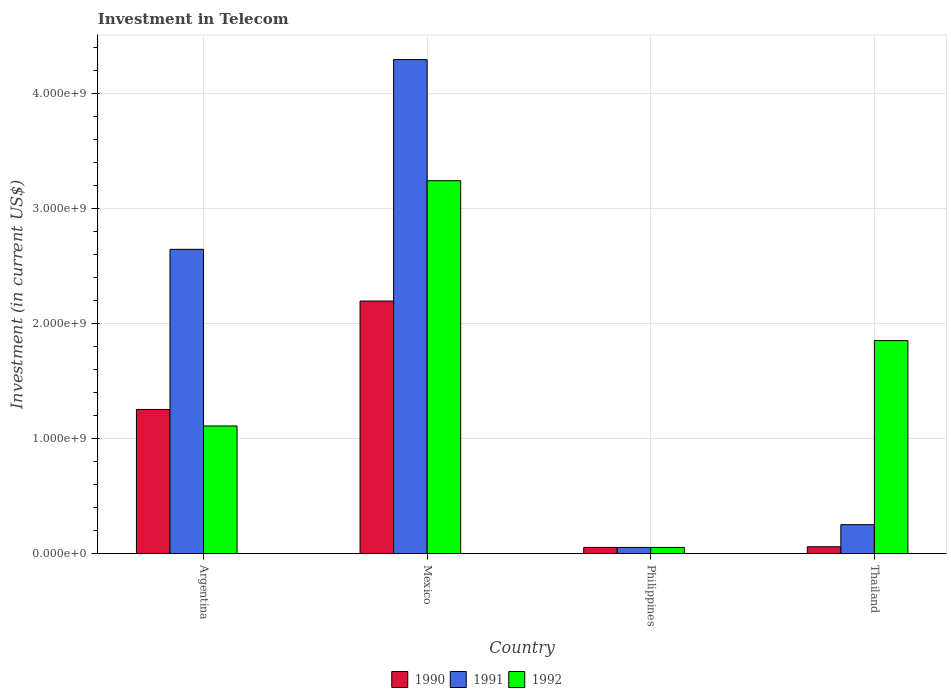How many groups of bars are there?
Offer a terse response. 4. How many bars are there on the 4th tick from the right?
Give a very brief answer. 3. What is the label of the 3rd group of bars from the left?
Make the answer very short. Philippines. What is the amount invested in telecom in 1990 in Mexico?
Offer a very short reply. 2.20e+09. Across all countries, what is the maximum amount invested in telecom in 1992?
Provide a succinct answer. 3.24e+09. Across all countries, what is the minimum amount invested in telecom in 1992?
Offer a very short reply. 5.42e+07. In which country was the amount invested in telecom in 1991 maximum?
Offer a very short reply. Mexico. In which country was the amount invested in telecom in 1991 minimum?
Provide a succinct answer. Philippines. What is the total amount invested in telecom in 1992 in the graph?
Offer a very short reply. 6.26e+09. What is the difference between the amount invested in telecom in 1990 in Argentina and that in Thailand?
Ensure brevity in your answer.  1.19e+09. What is the difference between the amount invested in telecom in 1992 in Mexico and the amount invested in telecom in 1991 in Philippines?
Make the answer very short. 3.19e+09. What is the average amount invested in telecom in 1992 per country?
Your answer should be compact. 1.57e+09. What is the difference between the amount invested in telecom of/in 1991 and amount invested in telecom of/in 1990 in Thailand?
Make the answer very short. 1.92e+08. In how many countries, is the amount invested in telecom in 1992 greater than 2200000000 US$?
Your response must be concise. 1. What is the ratio of the amount invested in telecom in 1992 in Argentina to that in Mexico?
Make the answer very short. 0.34. What is the difference between the highest and the second highest amount invested in telecom in 1990?
Make the answer very short. 2.14e+09. What is the difference between the highest and the lowest amount invested in telecom in 1992?
Keep it short and to the point. 3.19e+09. In how many countries, is the amount invested in telecom in 1990 greater than the average amount invested in telecom in 1990 taken over all countries?
Make the answer very short. 2. What does the 2nd bar from the left in Mexico represents?
Ensure brevity in your answer.  1991. How many bars are there?
Provide a succinct answer. 12. Are all the bars in the graph horizontal?
Provide a succinct answer. No. How many countries are there in the graph?
Ensure brevity in your answer.  4. What is the difference between two consecutive major ticks on the Y-axis?
Keep it short and to the point. 1.00e+09. Does the graph contain any zero values?
Make the answer very short. No. Does the graph contain grids?
Offer a terse response. Yes. How are the legend labels stacked?
Ensure brevity in your answer.  Horizontal. What is the title of the graph?
Offer a very short reply. Investment in Telecom. Does "2009" appear as one of the legend labels in the graph?
Offer a very short reply. No. What is the label or title of the Y-axis?
Offer a very short reply. Investment (in current US$). What is the Investment (in current US$) of 1990 in Argentina?
Your answer should be compact. 1.25e+09. What is the Investment (in current US$) in 1991 in Argentina?
Your response must be concise. 2.65e+09. What is the Investment (in current US$) in 1992 in Argentina?
Provide a succinct answer. 1.11e+09. What is the Investment (in current US$) of 1990 in Mexico?
Your answer should be very brief. 2.20e+09. What is the Investment (in current US$) in 1991 in Mexico?
Give a very brief answer. 4.30e+09. What is the Investment (in current US$) of 1992 in Mexico?
Your response must be concise. 3.24e+09. What is the Investment (in current US$) of 1990 in Philippines?
Provide a succinct answer. 5.42e+07. What is the Investment (in current US$) of 1991 in Philippines?
Offer a very short reply. 5.42e+07. What is the Investment (in current US$) of 1992 in Philippines?
Provide a succinct answer. 5.42e+07. What is the Investment (in current US$) in 1990 in Thailand?
Your response must be concise. 6.00e+07. What is the Investment (in current US$) of 1991 in Thailand?
Keep it short and to the point. 2.52e+08. What is the Investment (in current US$) of 1992 in Thailand?
Ensure brevity in your answer.  1.85e+09. Across all countries, what is the maximum Investment (in current US$) in 1990?
Offer a very short reply. 2.20e+09. Across all countries, what is the maximum Investment (in current US$) of 1991?
Make the answer very short. 4.30e+09. Across all countries, what is the maximum Investment (in current US$) in 1992?
Keep it short and to the point. 3.24e+09. Across all countries, what is the minimum Investment (in current US$) in 1990?
Make the answer very short. 5.42e+07. Across all countries, what is the minimum Investment (in current US$) in 1991?
Provide a succinct answer. 5.42e+07. Across all countries, what is the minimum Investment (in current US$) of 1992?
Ensure brevity in your answer.  5.42e+07. What is the total Investment (in current US$) of 1990 in the graph?
Make the answer very short. 3.57e+09. What is the total Investment (in current US$) in 1991 in the graph?
Provide a short and direct response. 7.25e+09. What is the total Investment (in current US$) of 1992 in the graph?
Provide a succinct answer. 6.26e+09. What is the difference between the Investment (in current US$) of 1990 in Argentina and that in Mexico?
Keep it short and to the point. -9.43e+08. What is the difference between the Investment (in current US$) of 1991 in Argentina and that in Mexico?
Keep it short and to the point. -1.65e+09. What is the difference between the Investment (in current US$) of 1992 in Argentina and that in Mexico?
Your answer should be compact. -2.13e+09. What is the difference between the Investment (in current US$) of 1990 in Argentina and that in Philippines?
Keep it short and to the point. 1.20e+09. What is the difference between the Investment (in current US$) in 1991 in Argentina and that in Philippines?
Your response must be concise. 2.59e+09. What is the difference between the Investment (in current US$) of 1992 in Argentina and that in Philippines?
Your answer should be compact. 1.06e+09. What is the difference between the Investment (in current US$) in 1990 in Argentina and that in Thailand?
Ensure brevity in your answer.  1.19e+09. What is the difference between the Investment (in current US$) in 1991 in Argentina and that in Thailand?
Ensure brevity in your answer.  2.40e+09. What is the difference between the Investment (in current US$) in 1992 in Argentina and that in Thailand?
Keep it short and to the point. -7.43e+08. What is the difference between the Investment (in current US$) of 1990 in Mexico and that in Philippines?
Provide a short and direct response. 2.14e+09. What is the difference between the Investment (in current US$) of 1991 in Mexico and that in Philippines?
Offer a very short reply. 4.24e+09. What is the difference between the Investment (in current US$) in 1992 in Mexico and that in Philippines?
Give a very brief answer. 3.19e+09. What is the difference between the Investment (in current US$) in 1990 in Mexico and that in Thailand?
Offer a terse response. 2.14e+09. What is the difference between the Investment (in current US$) in 1991 in Mexico and that in Thailand?
Keep it short and to the point. 4.05e+09. What is the difference between the Investment (in current US$) in 1992 in Mexico and that in Thailand?
Keep it short and to the point. 1.39e+09. What is the difference between the Investment (in current US$) of 1990 in Philippines and that in Thailand?
Your answer should be compact. -5.80e+06. What is the difference between the Investment (in current US$) of 1991 in Philippines and that in Thailand?
Offer a terse response. -1.98e+08. What is the difference between the Investment (in current US$) of 1992 in Philippines and that in Thailand?
Your answer should be compact. -1.80e+09. What is the difference between the Investment (in current US$) in 1990 in Argentina and the Investment (in current US$) in 1991 in Mexico?
Provide a short and direct response. -3.04e+09. What is the difference between the Investment (in current US$) of 1990 in Argentina and the Investment (in current US$) of 1992 in Mexico?
Ensure brevity in your answer.  -1.99e+09. What is the difference between the Investment (in current US$) in 1991 in Argentina and the Investment (in current US$) in 1992 in Mexico?
Offer a very short reply. -5.97e+08. What is the difference between the Investment (in current US$) of 1990 in Argentina and the Investment (in current US$) of 1991 in Philippines?
Provide a succinct answer. 1.20e+09. What is the difference between the Investment (in current US$) of 1990 in Argentina and the Investment (in current US$) of 1992 in Philippines?
Your response must be concise. 1.20e+09. What is the difference between the Investment (in current US$) of 1991 in Argentina and the Investment (in current US$) of 1992 in Philippines?
Make the answer very short. 2.59e+09. What is the difference between the Investment (in current US$) of 1990 in Argentina and the Investment (in current US$) of 1991 in Thailand?
Provide a succinct answer. 1.00e+09. What is the difference between the Investment (in current US$) of 1990 in Argentina and the Investment (in current US$) of 1992 in Thailand?
Provide a short and direct response. -5.99e+08. What is the difference between the Investment (in current US$) in 1991 in Argentina and the Investment (in current US$) in 1992 in Thailand?
Keep it short and to the point. 7.94e+08. What is the difference between the Investment (in current US$) in 1990 in Mexico and the Investment (in current US$) in 1991 in Philippines?
Make the answer very short. 2.14e+09. What is the difference between the Investment (in current US$) of 1990 in Mexico and the Investment (in current US$) of 1992 in Philippines?
Make the answer very short. 2.14e+09. What is the difference between the Investment (in current US$) in 1991 in Mexico and the Investment (in current US$) in 1992 in Philippines?
Your answer should be very brief. 4.24e+09. What is the difference between the Investment (in current US$) of 1990 in Mexico and the Investment (in current US$) of 1991 in Thailand?
Provide a succinct answer. 1.95e+09. What is the difference between the Investment (in current US$) of 1990 in Mexico and the Investment (in current US$) of 1992 in Thailand?
Offer a very short reply. 3.44e+08. What is the difference between the Investment (in current US$) in 1991 in Mexico and the Investment (in current US$) in 1992 in Thailand?
Your answer should be compact. 2.44e+09. What is the difference between the Investment (in current US$) in 1990 in Philippines and the Investment (in current US$) in 1991 in Thailand?
Your response must be concise. -1.98e+08. What is the difference between the Investment (in current US$) in 1990 in Philippines and the Investment (in current US$) in 1992 in Thailand?
Give a very brief answer. -1.80e+09. What is the difference between the Investment (in current US$) of 1991 in Philippines and the Investment (in current US$) of 1992 in Thailand?
Your answer should be compact. -1.80e+09. What is the average Investment (in current US$) of 1990 per country?
Make the answer very short. 8.92e+08. What is the average Investment (in current US$) in 1991 per country?
Offer a very short reply. 1.81e+09. What is the average Investment (in current US$) in 1992 per country?
Ensure brevity in your answer.  1.57e+09. What is the difference between the Investment (in current US$) of 1990 and Investment (in current US$) of 1991 in Argentina?
Offer a very short reply. -1.39e+09. What is the difference between the Investment (in current US$) of 1990 and Investment (in current US$) of 1992 in Argentina?
Offer a terse response. 1.44e+08. What is the difference between the Investment (in current US$) in 1991 and Investment (in current US$) in 1992 in Argentina?
Your response must be concise. 1.54e+09. What is the difference between the Investment (in current US$) of 1990 and Investment (in current US$) of 1991 in Mexico?
Provide a short and direct response. -2.10e+09. What is the difference between the Investment (in current US$) in 1990 and Investment (in current US$) in 1992 in Mexico?
Offer a terse response. -1.05e+09. What is the difference between the Investment (in current US$) in 1991 and Investment (in current US$) in 1992 in Mexico?
Ensure brevity in your answer.  1.05e+09. What is the difference between the Investment (in current US$) in 1990 and Investment (in current US$) in 1991 in Philippines?
Your answer should be very brief. 0. What is the difference between the Investment (in current US$) of 1990 and Investment (in current US$) of 1992 in Philippines?
Make the answer very short. 0. What is the difference between the Investment (in current US$) of 1991 and Investment (in current US$) of 1992 in Philippines?
Offer a very short reply. 0. What is the difference between the Investment (in current US$) in 1990 and Investment (in current US$) in 1991 in Thailand?
Offer a very short reply. -1.92e+08. What is the difference between the Investment (in current US$) in 1990 and Investment (in current US$) in 1992 in Thailand?
Provide a succinct answer. -1.79e+09. What is the difference between the Investment (in current US$) in 1991 and Investment (in current US$) in 1992 in Thailand?
Make the answer very short. -1.60e+09. What is the ratio of the Investment (in current US$) of 1990 in Argentina to that in Mexico?
Ensure brevity in your answer.  0.57. What is the ratio of the Investment (in current US$) of 1991 in Argentina to that in Mexico?
Ensure brevity in your answer.  0.62. What is the ratio of the Investment (in current US$) of 1992 in Argentina to that in Mexico?
Your answer should be compact. 0.34. What is the ratio of the Investment (in current US$) in 1990 in Argentina to that in Philippines?
Provide a short and direct response. 23.15. What is the ratio of the Investment (in current US$) of 1991 in Argentina to that in Philippines?
Provide a short and direct response. 48.86. What is the ratio of the Investment (in current US$) in 1992 in Argentina to that in Philippines?
Provide a short and direct response. 20.5. What is the ratio of the Investment (in current US$) in 1990 in Argentina to that in Thailand?
Keep it short and to the point. 20.91. What is the ratio of the Investment (in current US$) in 1991 in Argentina to that in Thailand?
Your response must be concise. 10.51. What is the ratio of the Investment (in current US$) in 1992 in Argentina to that in Thailand?
Make the answer very short. 0.6. What is the ratio of the Investment (in current US$) in 1990 in Mexico to that in Philippines?
Keep it short and to the point. 40.55. What is the ratio of the Investment (in current US$) of 1991 in Mexico to that in Philippines?
Keep it short and to the point. 79.32. What is the ratio of the Investment (in current US$) in 1992 in Mexico to that in Philippines?
Your response must be concise. 59.87. What is the ratio of the Investment (in current US$) of 1990 in Mexico to that in Thailand?
Your response must be concise. 36.63. What is the ratio of the Investment (in current US$) in 1991 in Mexico to that in Thailand?
Make the answer very short. 17.06. What is the ratio of the Investment (in current US$) of 1992 in Mexico to that in Thailand?
Offer a terse response. 1.75. What is the ratio of the Investment (in current US$) of 1990 in Philippines to that in Thailand?
Give a very brief answer. 0.9. What is the ratio of the Investment (in current US$) in 1991 in Philippines to that in Thailand?
Keep it short and to the point. 0.22. What is the ratio of the Investment (in current US$) in 1992 in Philippines to that in Thailand?
Provide a short and direct response. 0.03. What is the difference between the highest and the second highest Investment (in current US$) in 1990?
Your answer should be compact. 9.43e+08. What is the difference between the highest and the second highest Investment (in current US$) in 1991?
Give a very brief answer. 1.65e+09. What is the difference between the highest and the second highest Investment (in current US$) in 1992?
Offer a terse response. 1.39e+09. What is the difference between the highest and the lowest Investment (in current US$) in 1990?
Your response must be concise. 2.14e+09. What is the difference between the highest and the lowest Investment (in current US$) in 1991?
Keep it short and to the point. 4.24e+09. What is the difference between the highest and the lowest Investment (in current US$) in 1992?
Your response must be concise. 3.19e+09. 